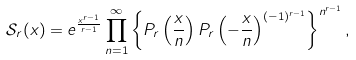<formula> <loc_0><loc_0><loc_500><loc_500>\mathcal { S } _ { r } ( x ) = e ^ { \frac { x ^ { r - 1 } } { r - 1 } } \prod _ { n = 1 } ^ { \infty } \left \{ P _ { r } \left ( \frac { x } { n } \right ) P _ { r } \left ( - \frac { x } { n } \right ) ^ { ( - 1 ) ^ { r - 1 } } \right \} ^ { n ^ { r - 1 } } ,</formula> 